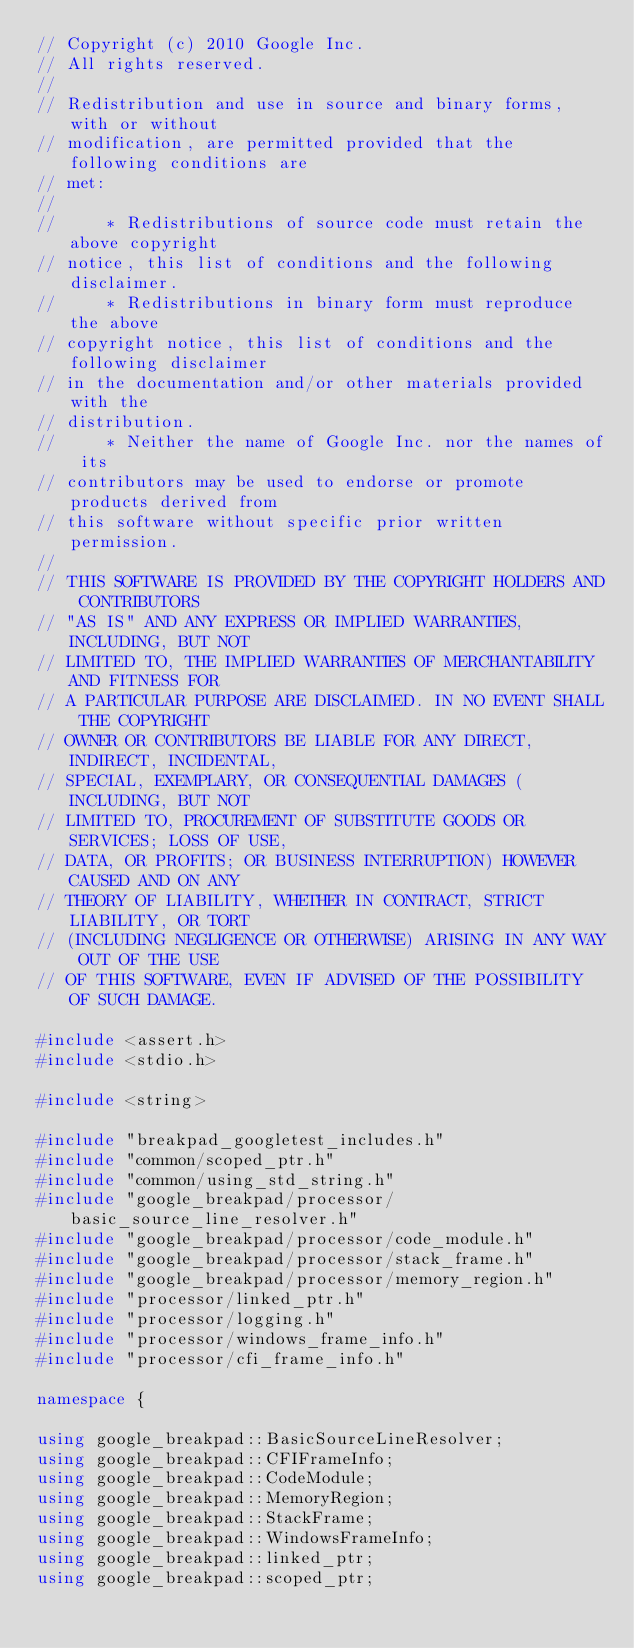<code> <loc_0><loc_0><loc_500><loc_500><_C++_>// Copyright (c) 2010 Google Inc.
// All rights reserved.
//
// Redistribution and use in source and binary forms, with or without
// modification, are permitted provided that the following conditions are
// met:
//
//     * Redistributions of source code must retain the above copyright
// notice, this list of conditions and the following disclaimer.
//     * Redistributions in binary form must reproduce the above
// copyright notice, this list of conditions and the following disclaimer
// in the documentation and/or other materials provided with the
// distribution.
//     * Neither the name of Google Inc. nor the names of its
// contributors may be used to endorse or promote products derived from
// this software without specific prior written permission.
//
// THIS SOFTWARE IS PROVIDED BY THE COPYRIGHT HOLDERS AND CONTRIBUTORS
// "AS IS" AND ANY EXPRESS OR IMPLIED WARRANTIES, INCLUDING, BUT NOT
// LIMITED TO, THE IMPLIED WARRANTIES OF MERCHANTABILITY AND FITNESS FOR
// A PARTICULAR PURPOSE ARE DISCLAIMED. IN NO EVENT SHALL THE COPYRIGHT
// OWNER OR CONTRIBUTORS BE LIABLE FOR ANY DIRECT, INDIRECT, INCIDENTAL,
// SPECIAL, EXEMPLARY, OR CONSEQUENTIAL DAMAGES (INCLUDING, BUT NOT
// LIMITED TO, PROCUREMENT OF SUBSTITUTE GOODS OR SERVICES; LOSS OF USE,
// DATA, OR PROFITS; OR BUSINESS INTERRUPTION) HOWEVER CAUSED AND ON ANY
// THEORY OF LIABILITY, WHETHER IN CONTRACT, STRICT LIABILITY, OR TORT
// (INCLUDING NEGLIGENCE OR OTHERWISE) ARISING IN ANY WAY OUT OF THE USE
// OF THIS SOFTWARE, EVEN IF ADVISED OF THE POSSIBILITY OF SUCH DAMAGE.

#include <assert.h>
#include <stdio.h>

#include <string>

#include "breakpad_googletest_includes.h"
#include "common/scoped_ptr.h"
#include "common/using_std_string.h"
#include "google_breakpad/processor/basic_source_line_resolver.h"
#include "google_breakpad/processor/code_module.h"
#include "google_breakpad/processor/stack_frame.h"
#include "google_breakpad/processor/memory_region.h"
#include "processor/linked_ptr.h"
#include "processor/logging.h"
#include "processor/windows_frame_info.h"
#include "processor/cfi_frame_info.h"

namespace {

using google_breakpad::BasicSourceLineResolver;
using google_breakpad::CFIFrameInfo;
using google_breakpad::CodeModule;
using google_breakpad::MemoryRegion;
using google_breakpad::StackFrame;
using google_breakpad::WindowsFrameInfo;
using google_breakpad::linked_ptr;
using google_breakpad::scoped_ptr;</code> 